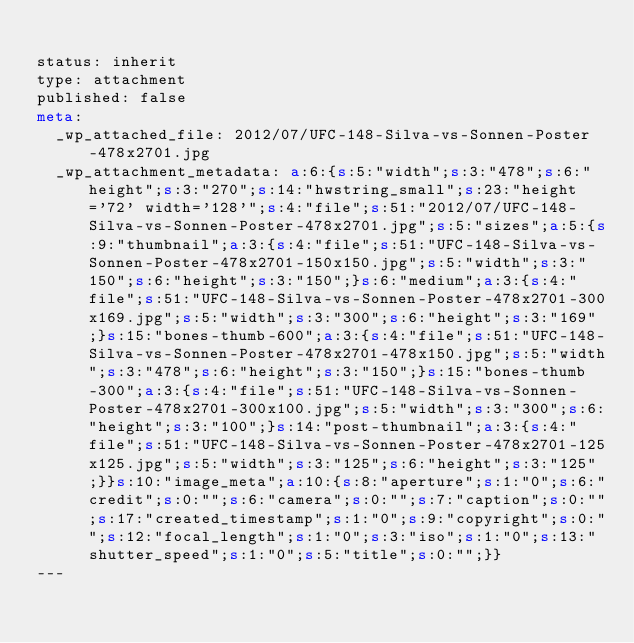<code> <loc_0><loc_0><loc_500><loc_500><_HTML_>
status: inherit
type: attachment
published: false
meta: 
  _wp_attached_file: 2012/07/UFC-148-Silva-vs-Sonnen-Poster-478x2701.jpg
  _wp_attachment_metadata: a:6:{s:5:"width";s:3:"478";s:6:"height";s:3:"270";s:14:"hwstring_small";s:23:"height='72' width='128'";s:4:"file";s:51:"2012/07/UFC-148-Silva-vs-Sonnen-Poster-478x2701.jpg";s:5:"sizes";a:5:{s:9:"thumbnail";a:3:{s:4:"file";s:51:"UFC-148-Silva-vs-Sonnen-Poster-478x2701-150x150.jpg";s:5:"width";s:3:"150";s:6:"height";s:3:"150";}s:6:"medium";a:3:{s:4:"file";s:51:"UFC-148-Silva-vs-Sonnen-Poster-478x2701-300x169.jpg";s:5:"width";s:3:"300";s:6:"height";s:3:"169";}s:15:"bones-thumb-600";a:3:{s:4:"file";s:51:"UFC-148-Silva-vs-Sonnen-Poster-478x2701-478x150.jpg";s:5:"width";s:3:"478";s:6:"height";s:3:"150";}s:15:"bones-thumb-300";a:3:{s:4:"file";s:51:"UFC-148-Silva-vs-Sonnen-Poster-478x2701-300x100.jpg";s:5:"width";s:3:"300";s:6:"height";s:3:"100";}s:14:"post-thumbnail";a:3:{s:4:"file";s:51:"UFC-148-Silva-vs-Sonnen-Poster-478x2701-125x125.jpg";s:5:"width";s:3:"125";s:6:"height";s:3:"125";}}s:10:"image_meta";a:10:{s:8:"aperture";s:1:"0";s:6:"credit";s:0:"";s:6:"camera";s:0:"";s:7:"caption";s:0:"";s:17:"created_timestamp";s:1:"0";s:9:"copyright";s:0:"";s:12:"focal_length";s:1:"0";s:3:"iso";s:1:"0";s:13:"shutter_speed";s:1:"0";s:5:"title";s:0:"";}}
---

</code> 